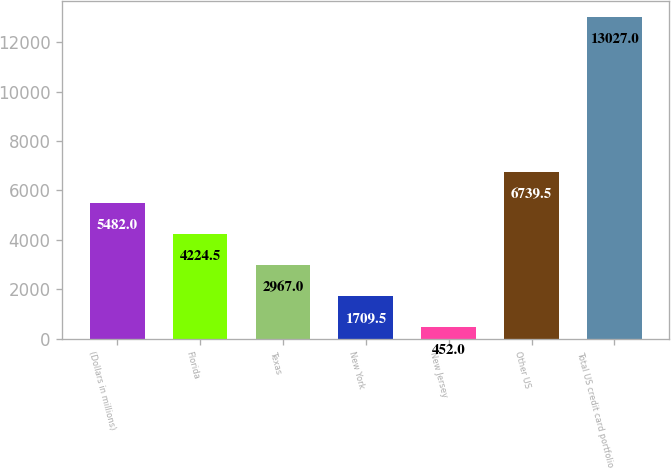Convert chart. <chart><loc_0><loc_0><loc_500><loc_500><bar_chart><fcel>(Dollars in millions)<fcel>Florida<fcel>Texas<fcel>New York<fcel>New Jersey<fcel>Other US<fcel>Total US credit card portfolio<nl><fcel>5482<fcel>4224.5<fcel>2967<fcel>1709.5<fcel>452<fcel>6739.5<fcel>13027<nl></chart> 